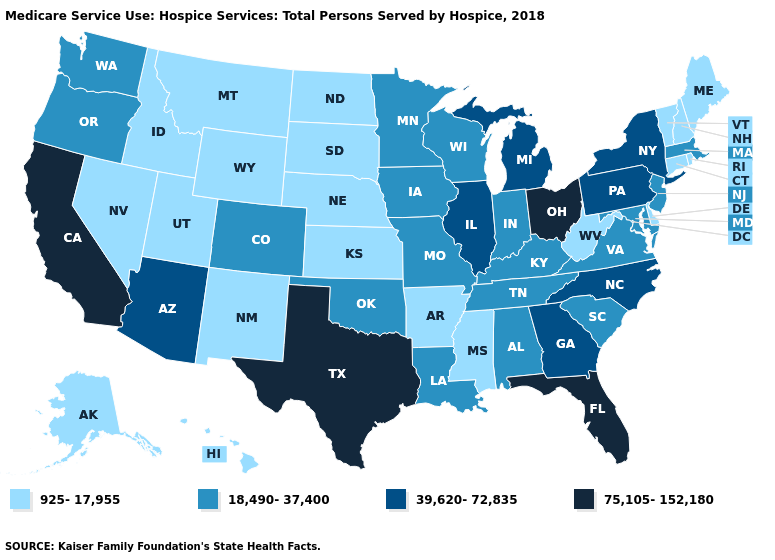Among the states that border Michigan , which have the highest value?
Concise answer only. Ohio. Does New Mexico have the lowest value in the West?
Concise answer only. Yes. Does the map have missing data?
Be succinct. No. Does West Virginia have the lowest value in the USA?
Quick response, please. Yes. Among the states that border Nevada , does California have the highest value?
Quick response, please. Yes. What is the value of Nevada?
Answer briefly. 925-17,955. What is the value of Ohio?
Be succinct. 75,105-152,180. What is the lowest value in states that border Minnesota?
Be succinct. 925-17,955. Does Florida have the highest value in the USA?
Quick response, please. Yes. Name the states that have a value in the range 18,490-37,400?
Short answer required. Alabama, Colorado, Indiana, Iowa, Kentucky, Louisiana, Maryland, Massachusetts, Minnesota, Missouri, New Jersey, Oklahoma, Oregon, South Carolina, Tennessee, Virginia, Washington, Wisconsin. Among the states that border Massachusetts , which have the lowest value?
Short answer required. Connecticut, New Hampshire, Rhode Island, Vermont. What is the lowest value in states that border Florida?
Quick response, please. 18,490-37,400. What is the highest value in the USA?
Be succinct. 75,105-152,180. Does Connecticut have a lower value than Utah?
Give a very brief answer. No. What is the lowest value in states that border Louisiana?
Short answer required. 925-17,955. 